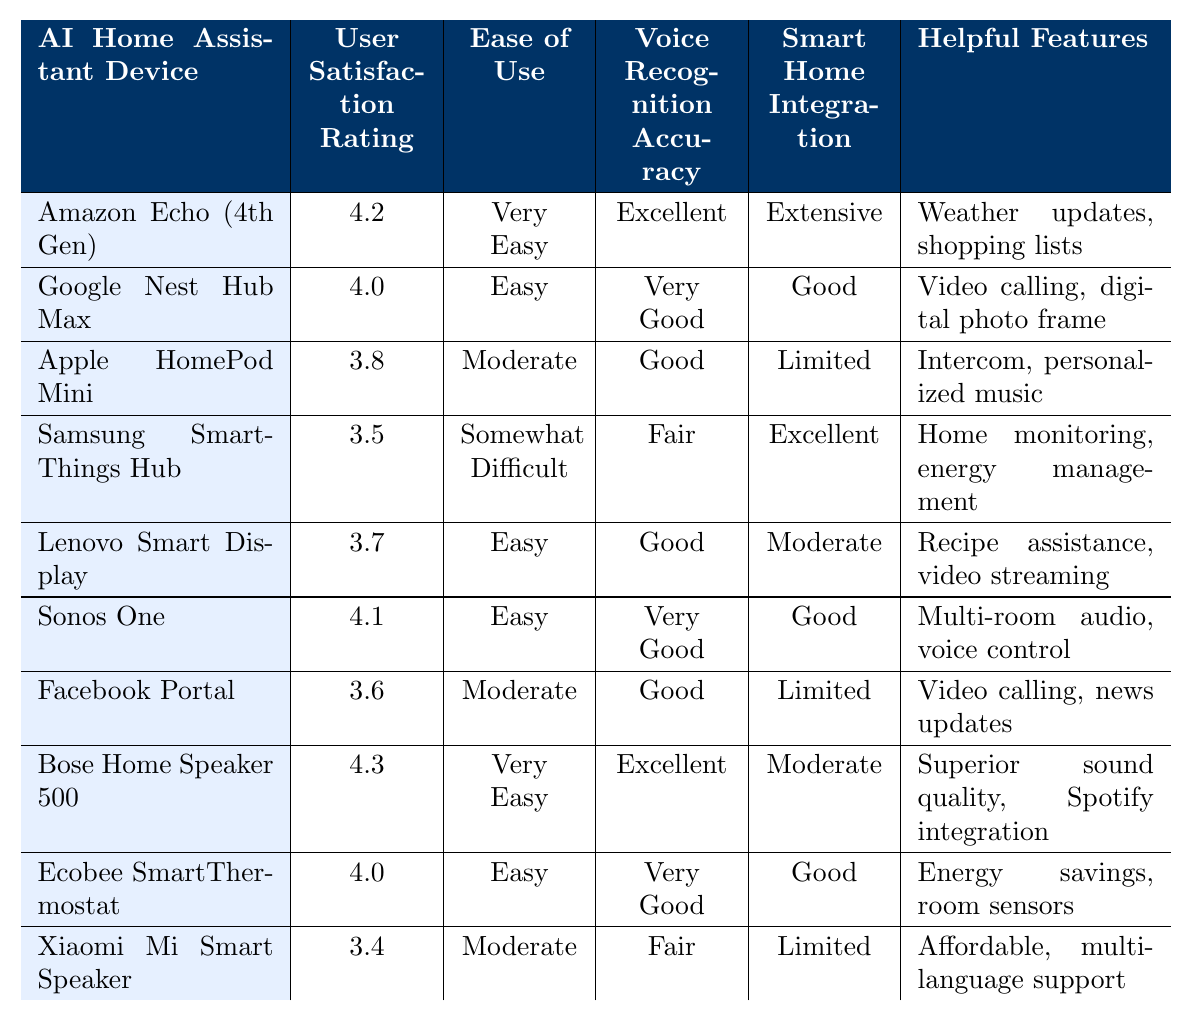What is the user satisfaction rating for the Amazon Echo (4th Gen)? The table shows the user satisfaction rating for the Amazon Echo (4th Gen) as 4.2 out of 5.
Answer: 4.2 Which device has the highest user satisfaction rating? The table indicates that the Bose Home Speaker 500 has the highest user satisfaction rating of 4.3 out of 5, which is greater than the ratings of all other devices listed.
Answer: Bose Home Speaker 500 What is the ease of use rating for the Apple HomePod Mini? According to the table, the ease of use rating for the Apple HomePod Mini is classified as "Moderate".
Answer: Moderate Are there any devices rated "Somewhat Difficult" in ease of use? Yes, the table lists the Samsung SmartThings Hub with an ease of use rating of "Somewhat Difficult."
Answer: Yes How many devices have a user satisfaction rating above 4.0? By reviewing the ratings, the Amazon Echo (4th Gen), Bose Home Speaker 500, and Sonos One have ratings above 4.0, totaling 3 devices.
Answer: 3 Calculate the average user satisfaction rating for all the devices listed. To find the average, sum the ratings (4.2 + 4.0 + 3.8 + 3.5 + 3.7 + 4.1 + 3.6 + 4.3 + 4.0 + 3.4) = 39.6. Then, divide by the number of devices (10) to get 39.6 / 10 = 3.96.
Answer: 3.96 Which device features energy management among its helpful features? The Samsung SmartThings Hub is noted for having energy management as one of its helpful features in the table.
Answer: Samsung SmartThings Hub Is there any device with limited smart home integration that also has a user satisfaction rating of 3.5 or higher? Yes, both the Apple HomePod Mini (Rated 3.8) and the Xiaomi Mi Smart Speaker (Rated 3.4) are noted to have limited smart home integration, but only the Apple HomePod Mini has a rating of 3.5 or higher.
Answer: Yes What features does the Google Nest Hub Max provide? The table states that the Google Nest Hub Max offers video calling and serves as a digital photo frame as helpful features.
Answer: Video calling, digital photo frame Which device has "Excellent" voice recognition accuracy and what is its user satisfaction rating? The Amazon Echo (4th Gen) and the Bose Home Speaker 500 are both rated "Excellent" for voice recognition accuracy, with user satisfaction ratings of 4.2 and 4.3, respectively.
Answer: Amazon Echo (4th Gen) and Bose Home Speaker 500; 4.2 and 4.3 